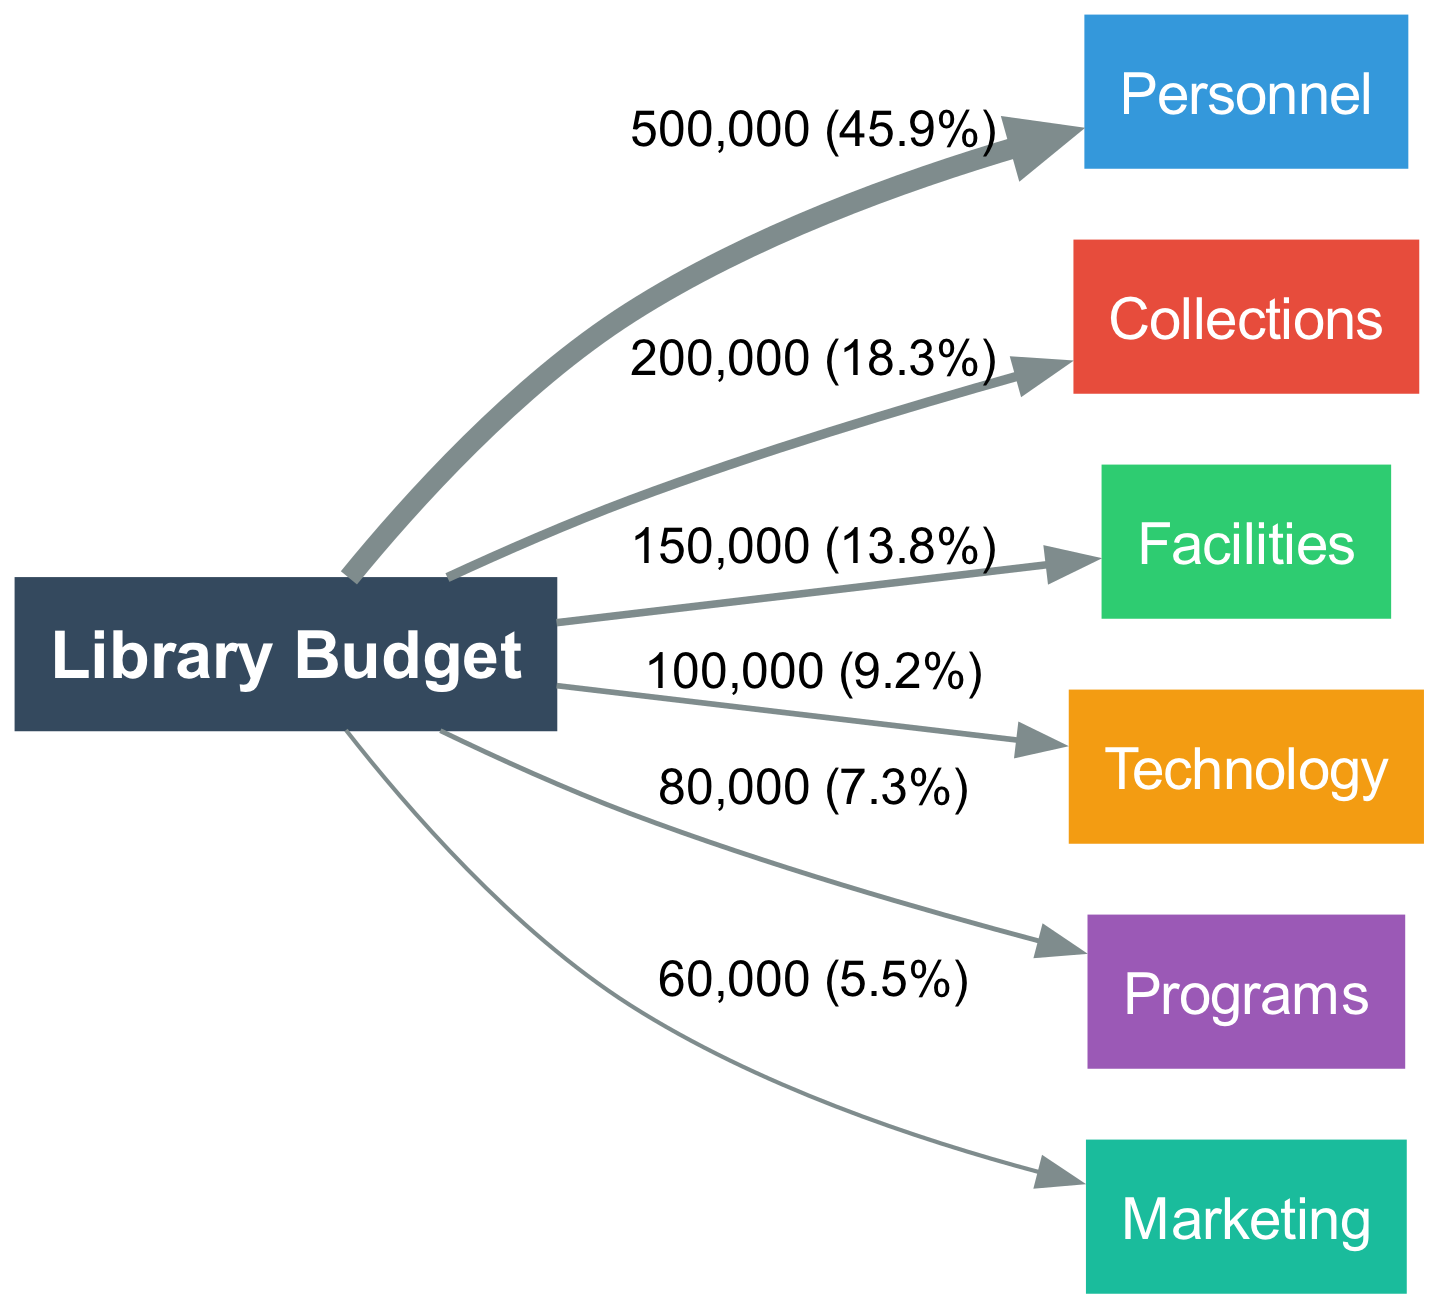What is the total library budget? The total library budget can be determined by summing all the individual allocations shown in the connections from the "Library Budget" node to other nodes. The values are 500,000 for Personnel, 200,000 for Collections, 150,000 for Facilities, 100,000 for Technology, 80,000 for Programs, and 60,000 for Marketing. Adding these gives 500,000 + 200,000 + 150,000 + 100,000 + 80,000 + 60,000 = 1,090,000.
Answer: 1,090,000 Which department receives the highest allocation? By examining the connections from the "Library Budget" node, we see that the Personnel department receives 500,000, which is the highest allocation compared to the others.
Answer: Personnel What percentage of the budget is allocated to Marketing? We need to first find the value allocated to Marketing, which is 60,000. Then, we calculate the percentage of the total budget, which is (60,000 / 1,090,000) * 100. This simplifies to approximately 5.5%, rounding to one decimal place.
Answer: 5.5% How many departments are funded? The diagram shows one source node "Library Budget" connected to six different target nodes representing departments and services. Counting these nodes gives us a total of six funded departments.
Answer: 6 What is the second largest allocation after Personnel? After finding that Personnel is allocated 500,000, we check the remaining amounts: Collections (200,000), Facilities (150,000), Technology (100,000), Programs (80,000), and Marketing (60,000). The largest after Personnel is Collections at 200,000.
Answer: Collections What is the value of the Technology allocation? The Technology department is directly connected to the "Library Budget" node, and the link value is labeled as 100,000. Therefore, this is the amount allocated to Technology.
Answer: 100,000 What is the total funding for Programs and Marketing combined? To find this, we sum the individual values allocated to both Programs and Marketing. Programs is allocated 80,000, and Marketing is allocated 60,000. Adding these values gives 80,000 + 60,000 = 140,000.
Answer: 140,000 Which two departments together receive more than 300,000? Observing the values allocated to each department, we find that Personnel (500,000) and Collections (200,000) together make 500,000 + 200,000 = 700,000. This exceeds 300,000. Additionally, Personnel and Facilities (150,000) also exceed this when combined (500,000 + 150,000 = 650,000). Thus, the departments are Personnel and Collections.
Answer: Personnel and Collections What is the ratio of the allocation for Facilities to the allocation for Technology? The value for Facilities is 150,000 and the value for Technology is 100,000. The ratio can be simplified by dividing these values: 150,000 / 100,000 = 1.5, therefore the ratio is 1.5:1.
Answer: 1.5:1 